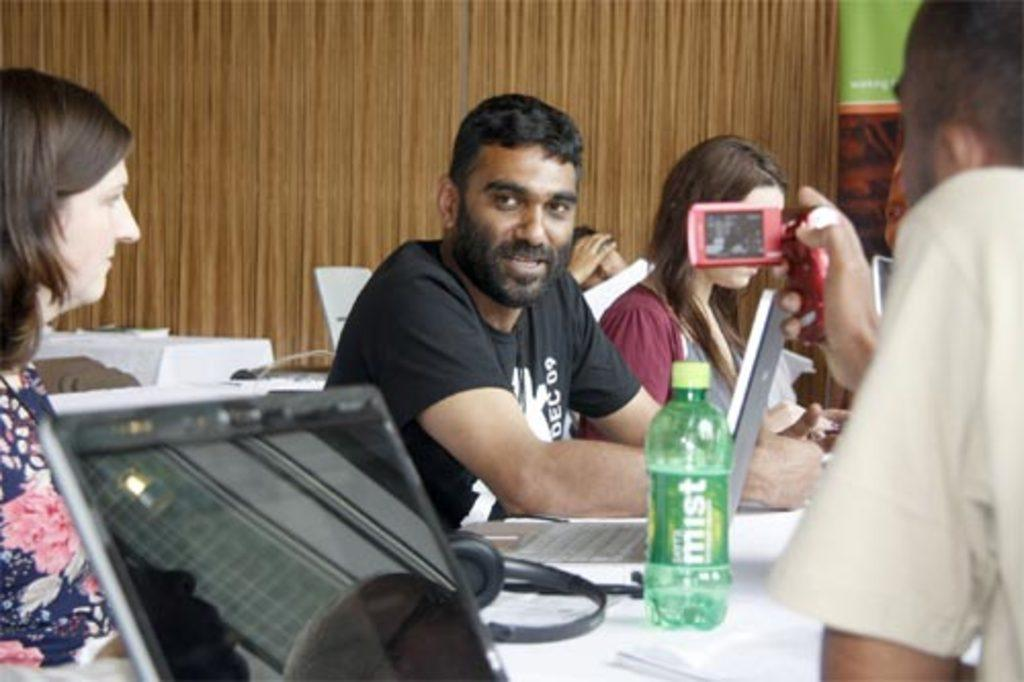What are the people in the image doing? The people in the image are sitting on chairs. What object can be seen on the table? There is a laptop on a table in the image. What else is present in the image? There is a bottle in the image. What activity is one of the people engaged in? A person is recording a video. What can be seen in the background of the image? There is a wall in the image. What type of clouds can be seen in the image? There are no clouds present in the image. What snack is being eaten by the people in the image? There is no mention of any snacks, including popcorn, in the image. 